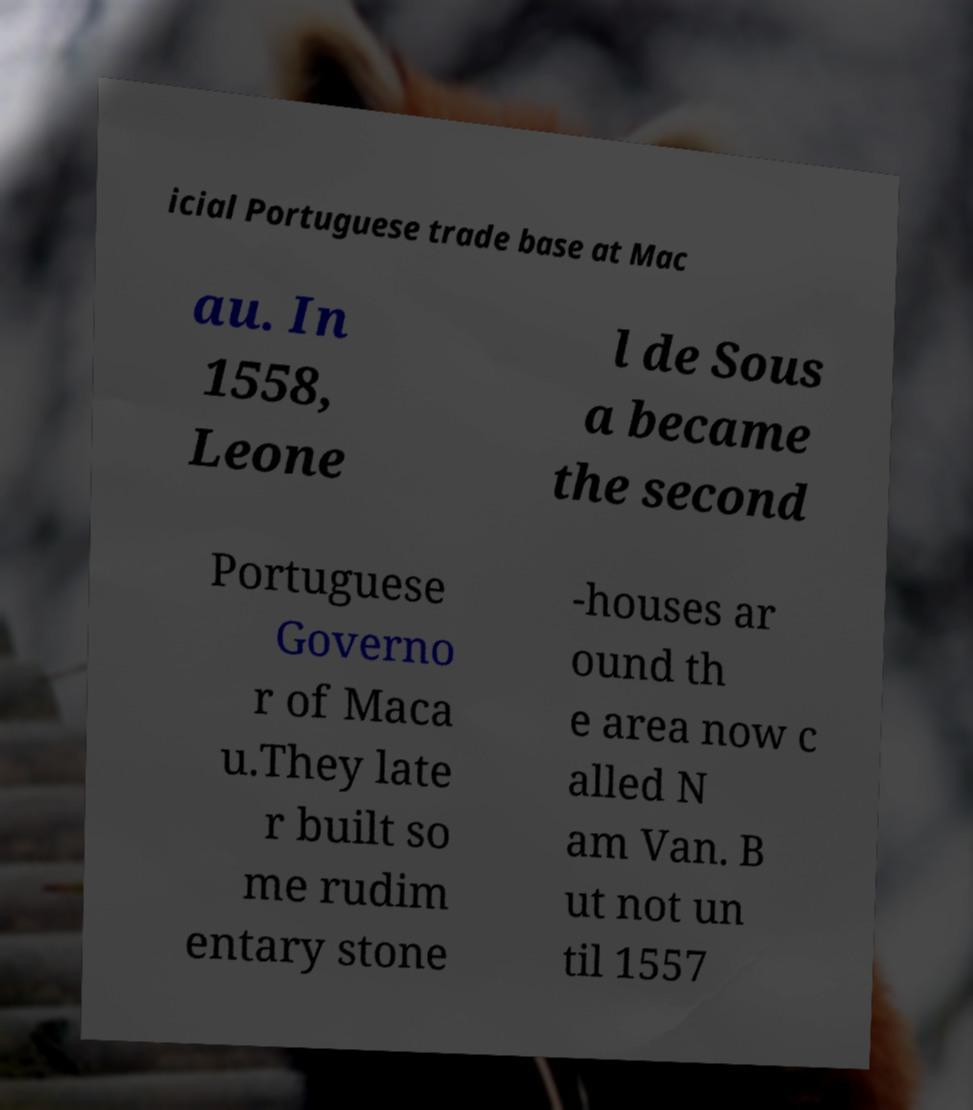Please read and relay the text visible in this image. What does it say? icial Portuguese trade base at Mac au. In 1558, Leone l de Sous a became the second Portuguese Governo r of Maca u.They late r built so me rudim entary stone -houses ar ound th e area now c alled N am Van. B ut not un til 1557 